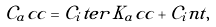<formula> <loc_0><loc_0><loc_500><loc_500>\mathcal { C } _ { a } c c = \mathcal { C } _ { i } t e r \, K _ { a } c c + \mathcal { C } _ { i } n t ,</formula> 